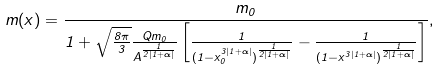Convert formula to latex. <formula><loc_0><loc_0><loc_500><loc_500>m ( x ) = \frac { m _ { 0 } } { 1 + \sqrt { \frac { 8 \pi } { 3 } } \frac { Q m _ { 0 } } { A ^ { \frac { 1 } { 2 | 1 + \alpha | } } } \left [ \frac { 1 } { ( 1 - x _ { 0 } ^ { 3 | 1 + \alpha | } ) ^ { \frac { 1 } { 2 | 1 + \alpha | } } } - \frac { 1 } { ( 1 - x ^ { 3 | 1 + \alpha | } ) ^ { \frac { 1 } { 2 | 1 + \alpha | } } } \right ] } ,</formula> 